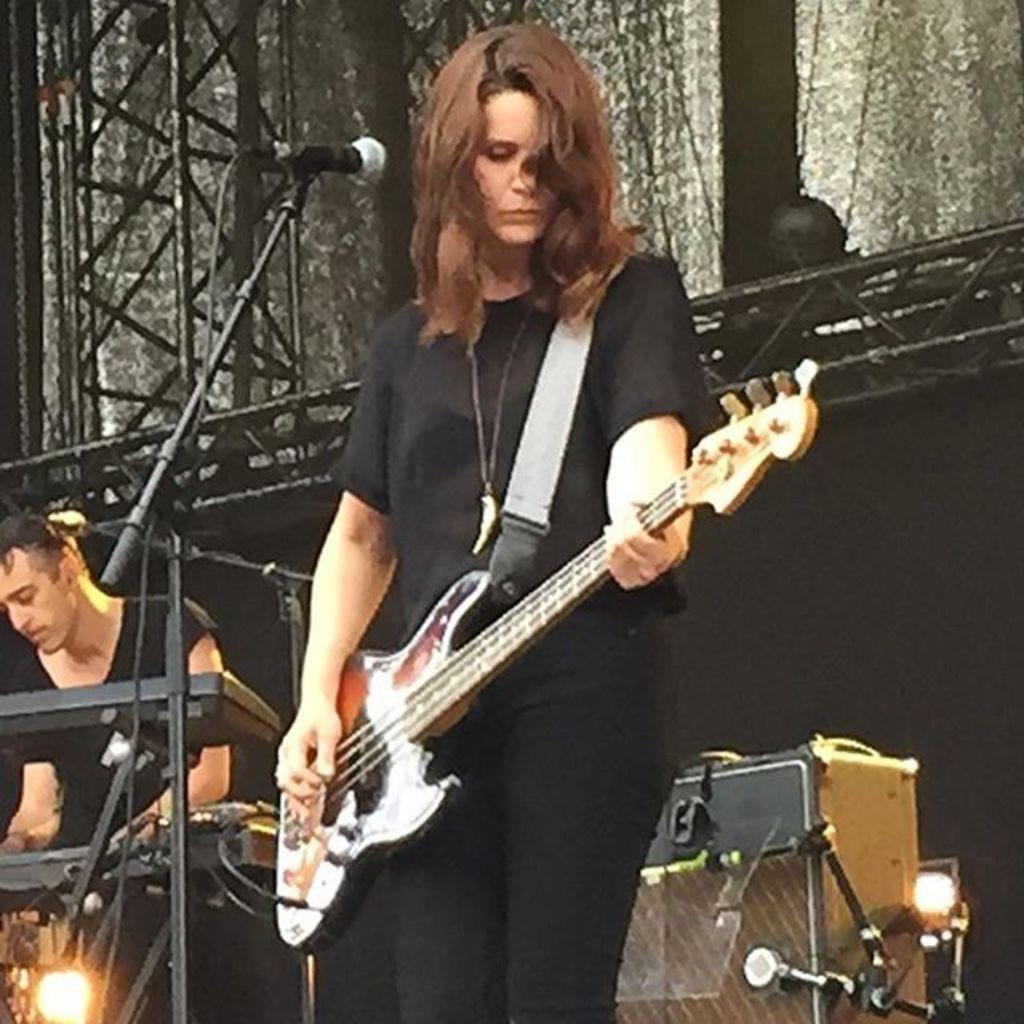How many people are present in the image? There are two people in the image. What are the people wearing? Both people are wearing black color dresses. What is the woman holding in the image? The woman is holding a guitar. What can be seen near the woman? There is a mic in the image. What other musical instrument is visible in the image? There is a musical keyboard in the image. What type of background can be seen in the image? There are curtains in the image. Can you see a cart being pushed by the people in the image? There is no cart present in the image. What type of cemetery can be seen in the background of the image? There is no cemetery present in the image; it features a woman holding a guitar, a mic, and a musical keyboard, with curtains in the background. 